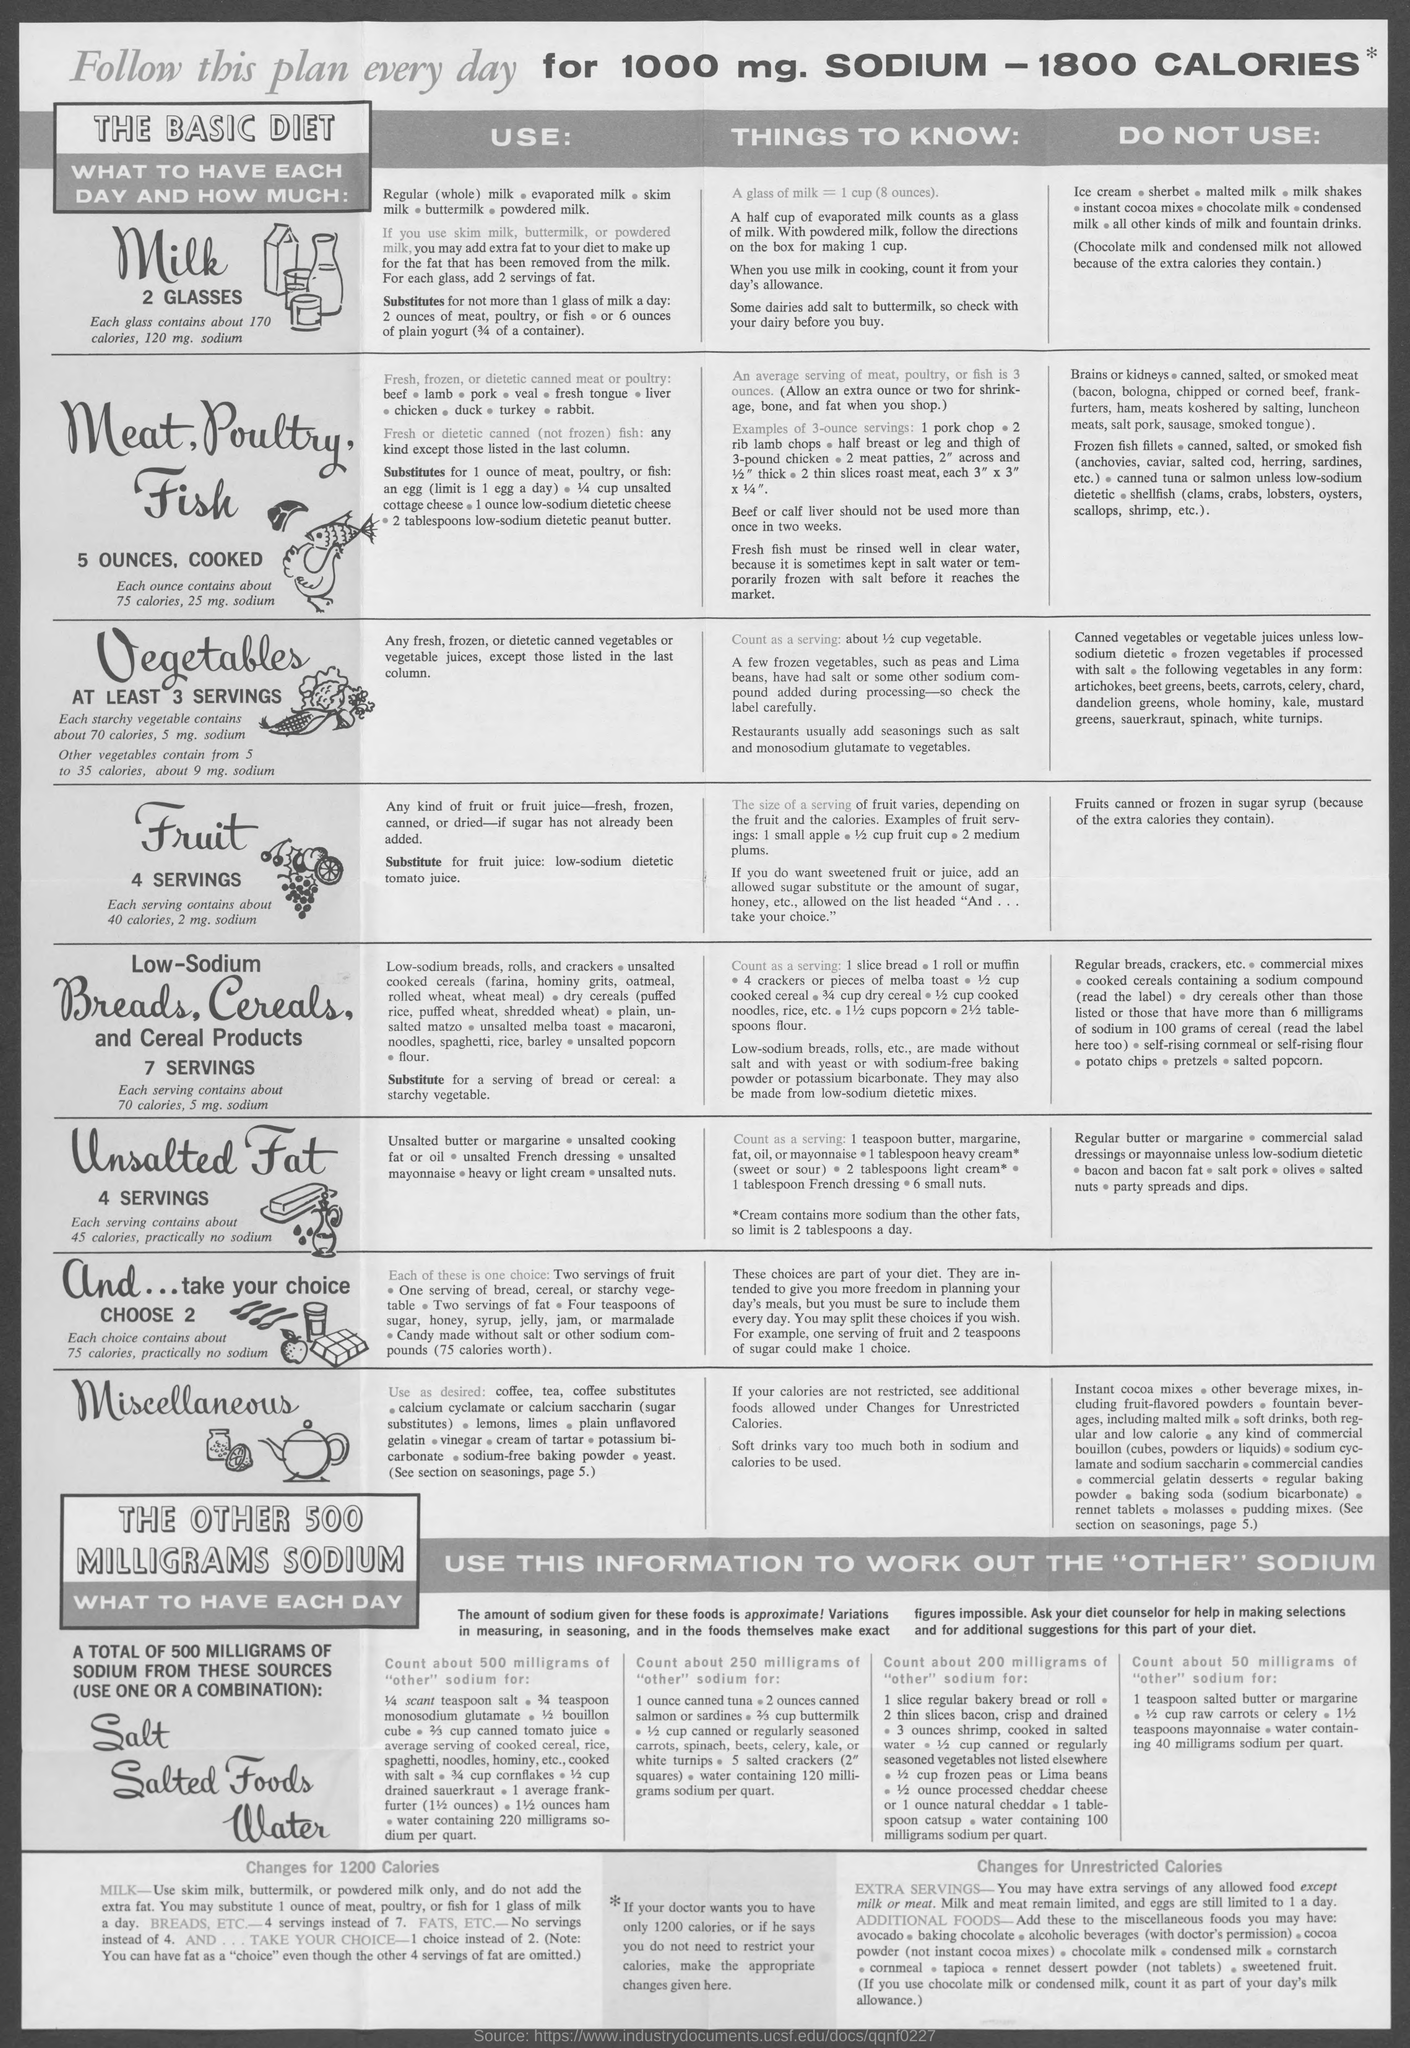Specify some key components in this picture. The recommended daily intake of milk is two glasses per day. Based on a calculation of 1000 milligrams of sodium and 1800 calories, the answer is: "The amount of calories for 1000 milligrams of sodium is [1800 calories]. 